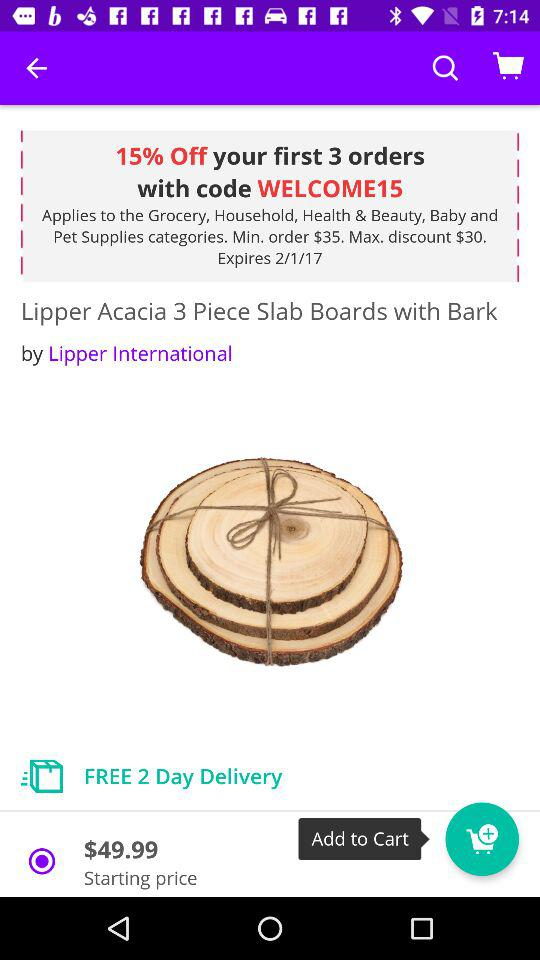In how many days will the order be delivered for free? The order will be delivered for free in two days. 